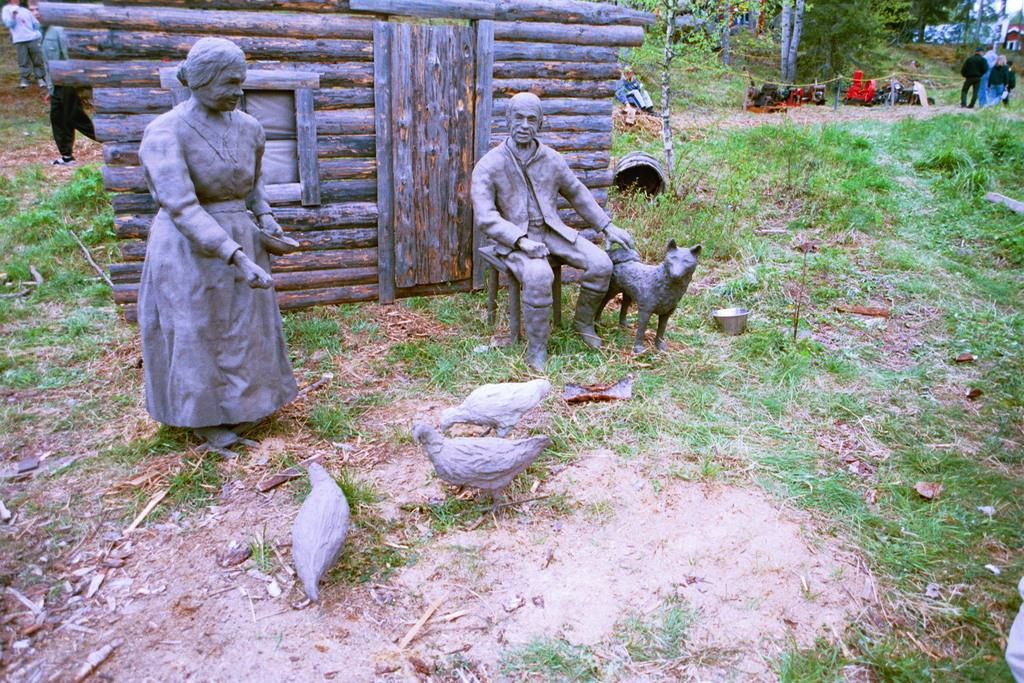What type of sculptures can be seen in the image? There are sculptures of people, birds, and an animal in the image. What is the natural environment like in the image? There is grass and trees visible in the image. Are there any people present in the image? Yes, there are people standing in the background of the image. Can you tell me how much salt is being requested by the animal sculpture in the image? There is no mention of salt or a request in the image; it features sculptures of people, birds, and an animal, as well as grass, trees, and people in the background. 